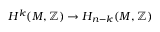<formula> <loc_0><loc_0><loc_500><loc_500>H ^ { k } ( M , \mathbb { Z } ) \to H _ { n - k } ( M , \mathbb { Z } )</formula> 